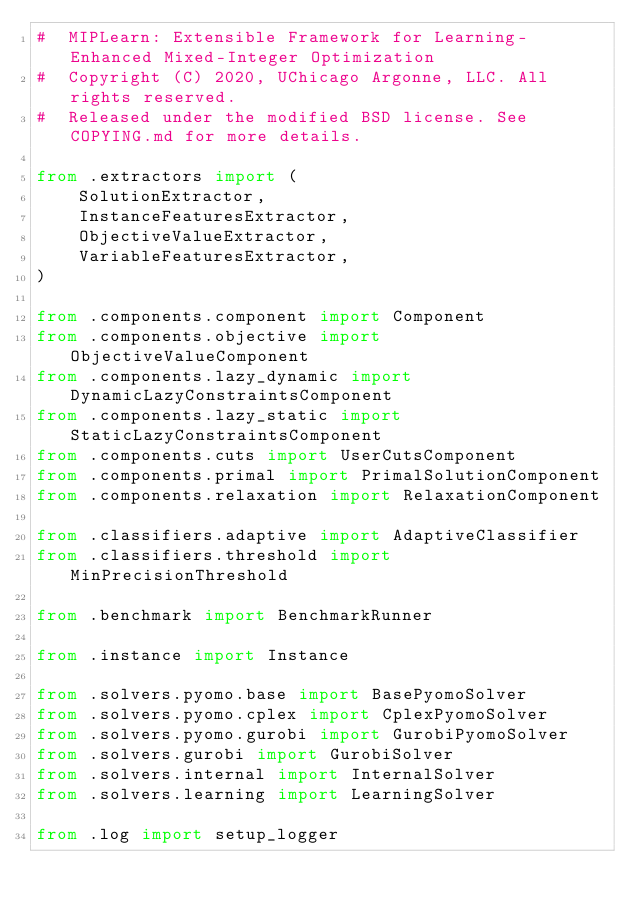Convert code to text. <code><loc_0><loc_0><loc_500><loc_500><_Python_>#  MIPLearn: Extensible Framework for Learning-Enhanced Mixed-Integer Optimization
#  Copyright (C) 2020, UChicago Argonne, LLC. All rights reserved.
#  Released under the modified BSD license. See COPYING.md for more details.

from .extractors import (
    SolutionExtractor,
    InstanceFeaturesExtractor,
    ObjectiveValueExtractor,
    VariableFeaturesExtractor,
)

from .components.component import Component
from .components.objective import ObjectiveValueComponent
from .components.lazy_dynamic import DynamicLazyConstraintsComponent
from .components.lazy_static import StaticLazyConstraintsComponent
from .components.cuts import UserCutsComponent
from .components.primal import PrimalSolutionComponent
from .components.relaxation import RelaxationComponent

from .classifiers.adaptive import AdaptiveClassifier
from .classifiers.threshold import MinPrecisionThreshold

from .benchmark import BenchmarkRunner

from .instance import Instance

from .solvers.pyomo.base import BasePyomoSolver
from .solvers.pyomo.cplex import CplexPyomoSolver
from .solvers.pyomo.gurobi import GurobiPyomoSolver
from .solvers.gurobi import GurobiSolver
from .solvers.internal import InternalSolver
from .solvers.learning import LearningSolver

from .log import setup_logger
</code> 